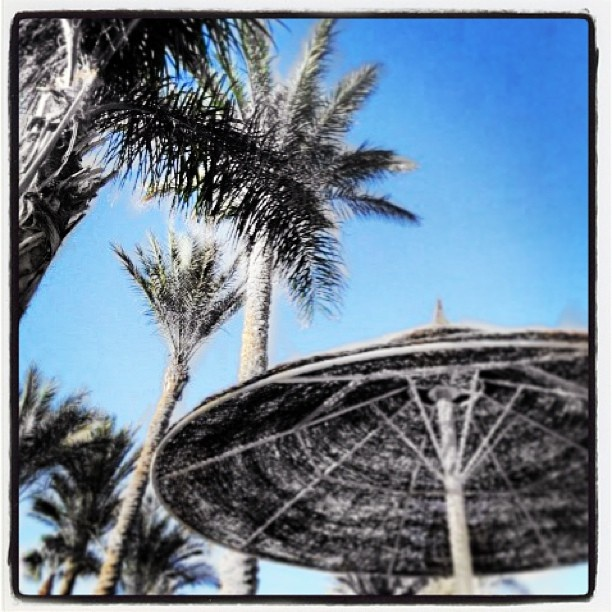Describe the objects in this image and their specific colors. I can see a umbrella in white, black, gray, darkgray, and lightgray tones in this image. 